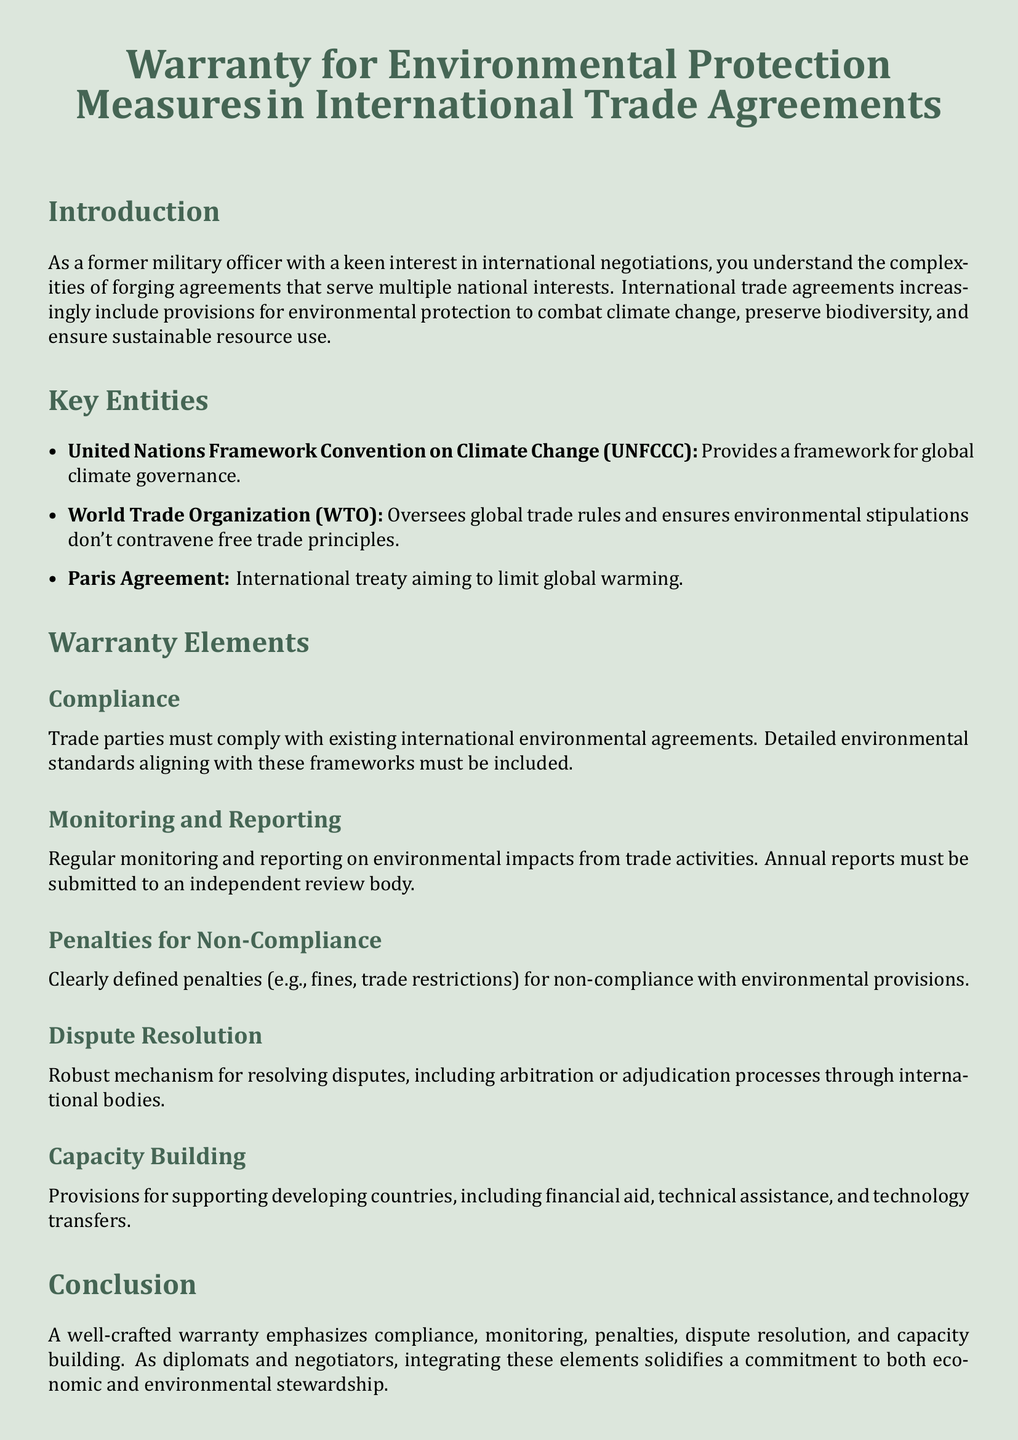What is the primary aim of including environmental provisions in trade agreements? The aim is to combat climate change, preserve biodiversity, and ensure sustainable resource use.
Answer: combat climate change, preserve biodiversity, ensure sustainable resource use Which organization provides a framework for global climate governance? The document states that the United Nations Framework Convention on Climate Change provides this framework.
Answer: United Nations Framework Convention on Climate Change What document is an international treaty aiming to limit global warming? The document mentions the Paris Agreement as the international treaty for this purpose.
Answer: Paris Agreement What must trade parties comply with according to the warranty elements? Trade parties must comply with existing international environmental agreements.
Answer: existing international environmental agreements What is required for monitoring and reporting according to the warranty? The warranty requires regular monitoring and reporting on environmental impacts from trade activities.
Answer: regular monitoring and reporting What kind of penalties are defined for non-compliance? The penalties defined include fines and trade restrictions.
Answer: fines, trade restrictions What support is mentioned for developing countries? The document states that provisions include financial aid, technical assistance, and technology transfers.
Answer: financial aid, technical assistance, technology transfers Which two processes are included in the dispute resolution mechanism? The document specifies arbitration or adjudication processes for resolving disputes.
Answer: arbitration, adjudication How often must reports on environmental impacts be submitted? The requirement is for annual reports to be submitted to an independent review body.
Answer: annual 